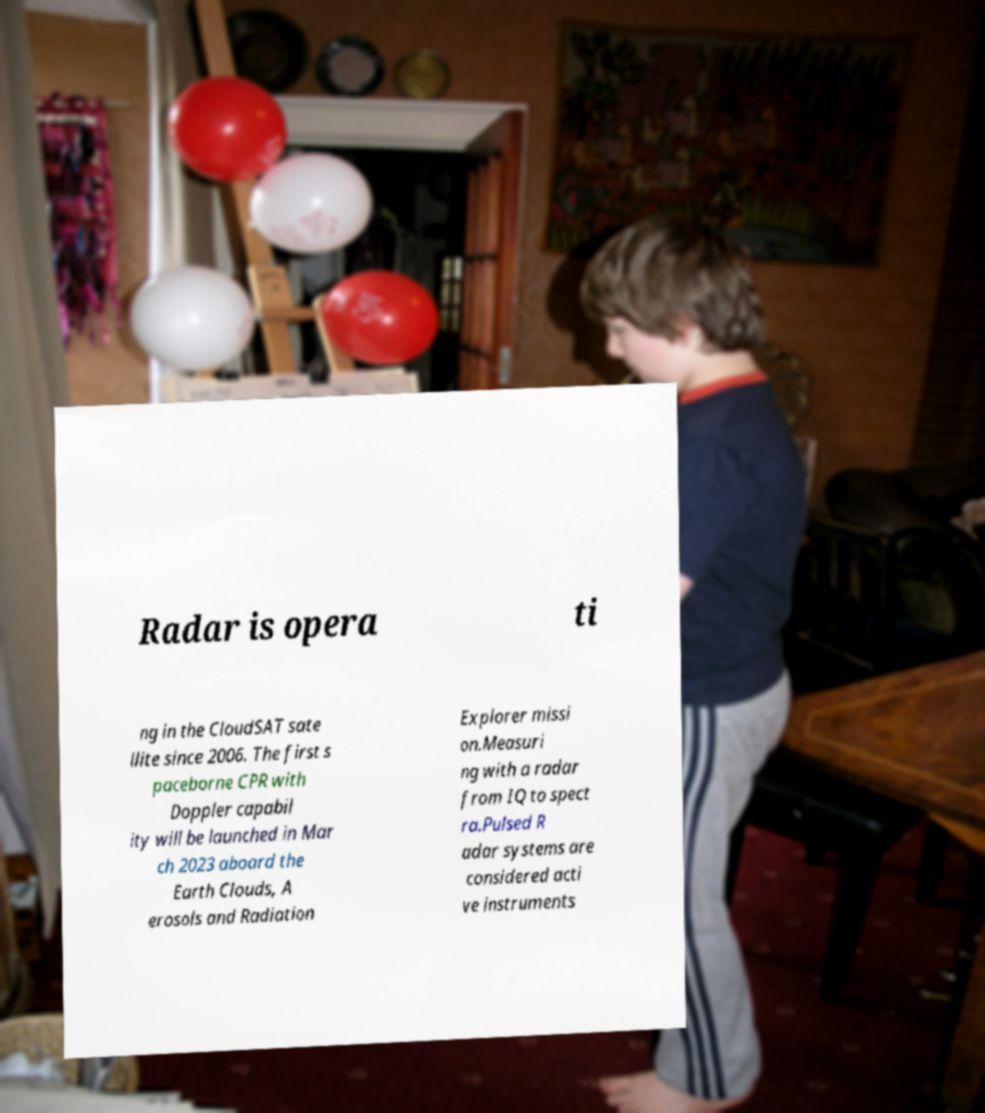Can you read and provide the text displayed in the image?This photo seems to have some interesting text. Can you extract and type it out for me? Radar is opera ti ng in the CloudSAT sate llite since 2006. The first s paceborne CPR with Doppler capabil ity will be launched in Mar ch 2023 aboard the Earth Clouds, A erosols and Radiation Explorer missi on.Measuri ng with a radar from IQ to spect ra.Pulsed R adar systems are considered acti ve instruments 